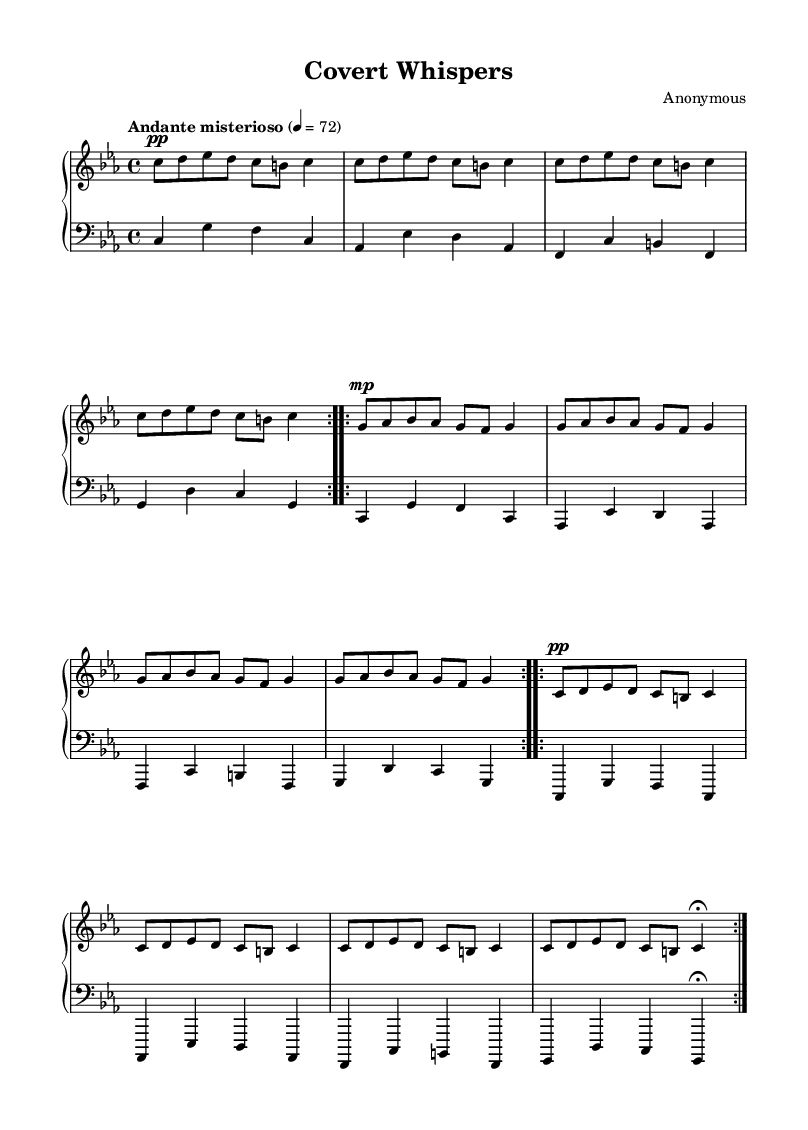What is the key signature of this music? The key signature is indicated at the beginning of the piece, which shows three flats. This corresponds to the key of C minor.
Answer: C minor What is the time signature of this music? The time signature is shown as a fraction at the beginning of the piece, which indicates there are four beats in each measure, denoted by "4/4".
Answer: 4/4 What is the tempo marking for this piece? The tempo marking is indicated at the beginning and states "Andante misterioso," which is a moderate tempo that conveys a mysterious character.
Answer: Andante misterioso How many times is the first theme repeated? By examining the measures, the first theme, also called a "volta," is repeated twice as indicated by the repeat sign before it.
Answer: 2 What dynamic marking is used for the opening measures? The opening measures feature a dynamic marking of "pp," which stands for "pianississimo," indicating very soft playing.
Answer: pp What is the finishing note of the last measure in the left hand? The final note of the last measure in the left hand is indicated by a fermata, which signifies that this note should be held longer than its typical value. Looking at the notation, the note is a G.
Answer: G How many sections are there in the right hand part? The right hand part contains three distinct sections, each introduced by a repeat sign indicating that these sections are repeated.
Answer: 3 